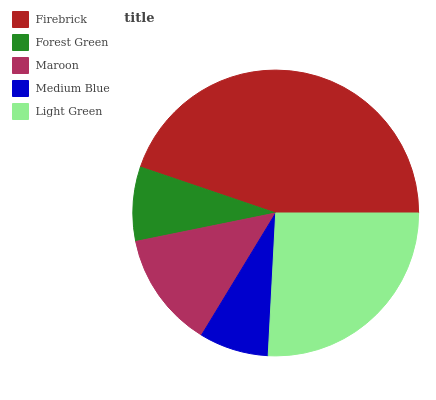Is Medium Blue the minimum?
Answer yes or no. Yes. Is Firebrick the maximum?
Answer yes or no. Yes. Is Forest Green the minimum?
Answer yes or no. No. Is Forest Green the maximum?
Answer yes or no. No. Is Firebrick greater than Forest Green?
Answer yes or no. Yes. Is Forest Green less than Firebrick?
Answer yes or no. Yes. Is Forest Green greater than Firebrick?
Answer yes or no. No. Is Firebrick less than Forest Green?
Answer yes or no. No. Is Maroon the high median?
Answer yes or no. Yes. Is Maroon the low median?
Answer yes or no. Yes. Is Light Green the high median?
Answer yes or no. No. Is Light Green the low median?
Answer yes or no. No. 